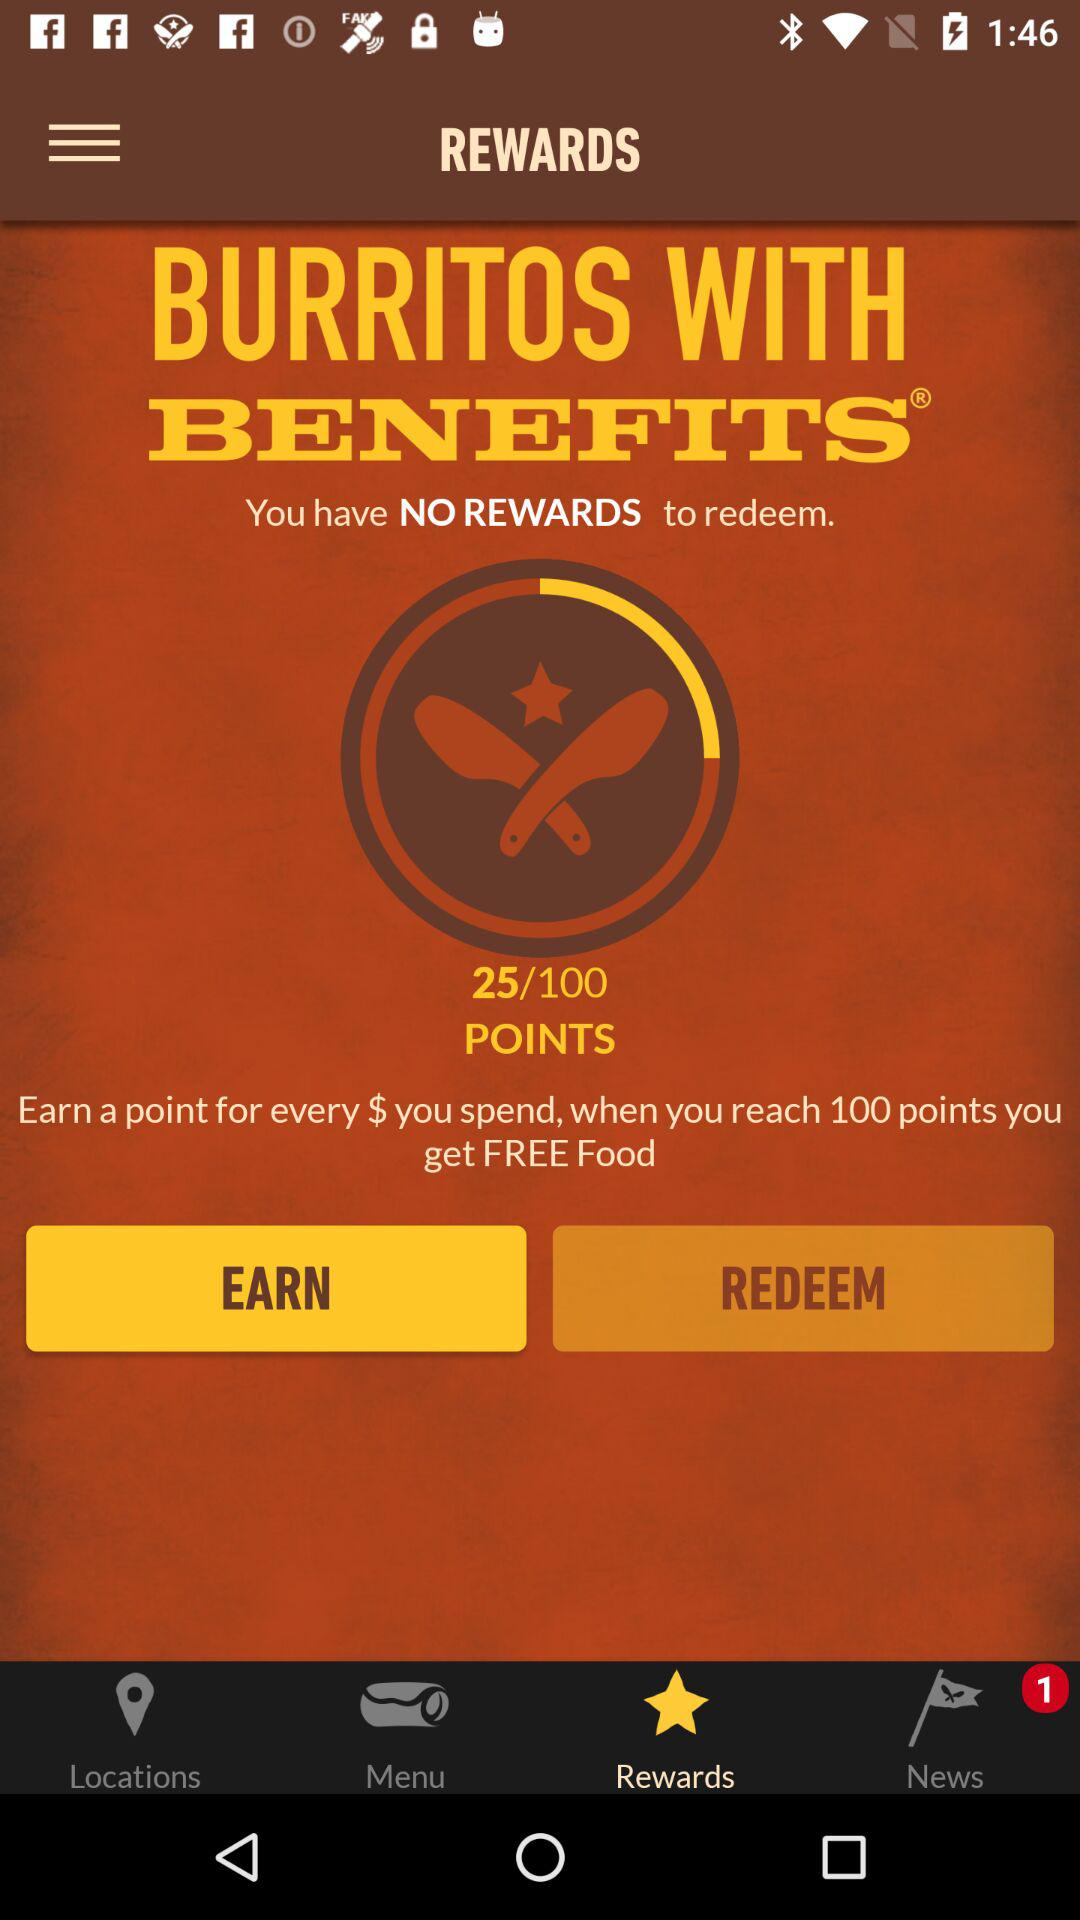How many rewards do I have?
Answer the question using a single word or phrase. 0 